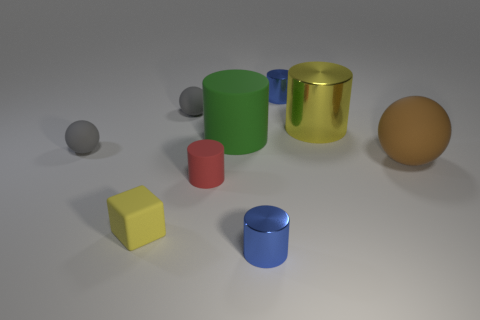Is the color of the large object to the left of the big yellow thing the same as the metallic cylinder in front of the big yellow metal thing?
Provide a succinct answer. No. Is the number of brown matte objects less than the number of small metal cylinders?
Offer a terse response. Yes. The tiny gray matte thing that is behind the gray thing in front of the yellow metal thing is what shape?
Your answer should be compact. Sphere. Are there any other things that have the same size as the red thing?
Your answer should be very brief. Yes. The gray matte object that is in front of the gray thing behind the green matte thing that is behind the red thing is what shape?
Offer a very short reply. Sphere. What number of objects are either matte objects that are in front of the large rubber ball or small blue metal cylinders in front of the brown object?
Give a very brief answer. 3. Is the size of the yellow cylinder the same as the shiny thing in front of the large sphere?
Your answer should be compact. No. Does the tiny red cylinder that is to the right of the rubber cube have the same material as the blue object that is behind the green matte thing?
Your response must be concise. No. Are there the same number of brown matte things right of the large rubber sphere and tiny shiny cylinders in front of the tiny rubber block?
Provide a short and direct response. No. How many big rubber spheres have the same color as the big shiny object?
Offer a very short reply. 0. 